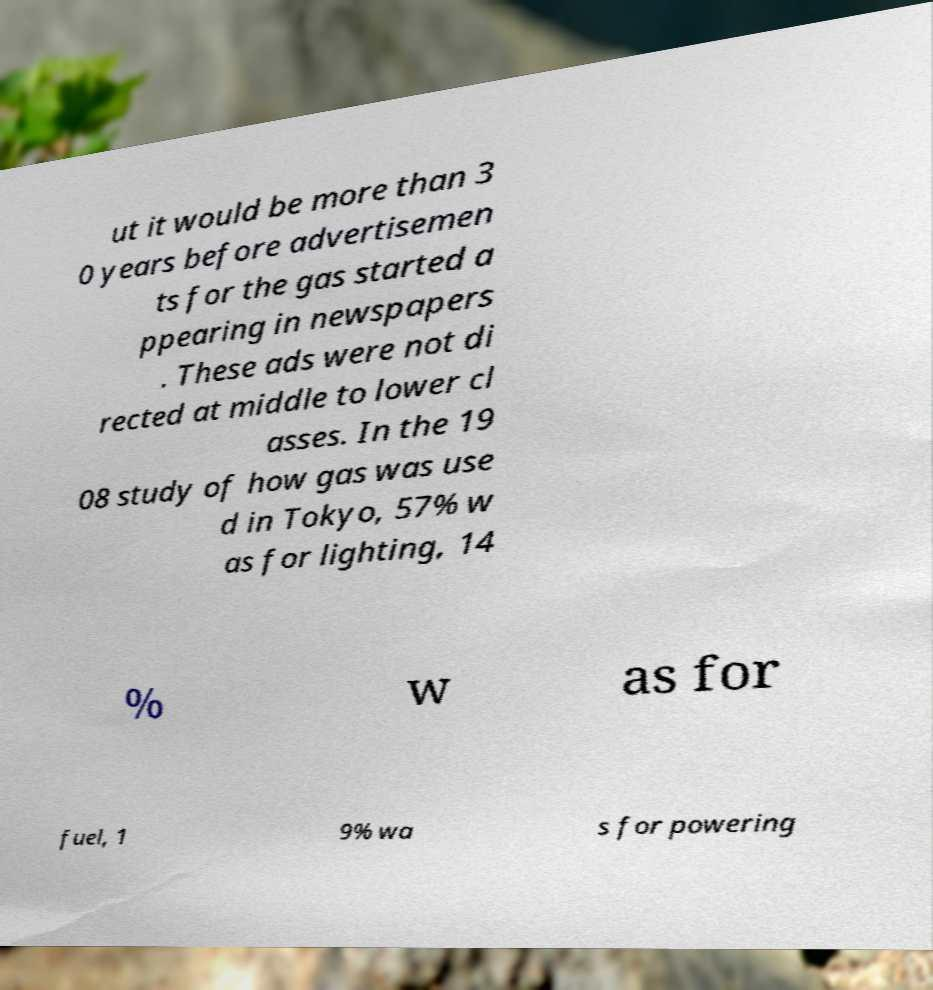Please read and relay the text visible in this image. What does it say? ut it would be more than 3 0 years before advertisemen ts for the gas started a ppearing in newspapers . These ads were not di rected at middle to lower cl asses. In the 19 08 study of how gas was use d in Tokyo, 57% w as for lighting, 14 % w as for fuel, 1 9% wa s for powering 